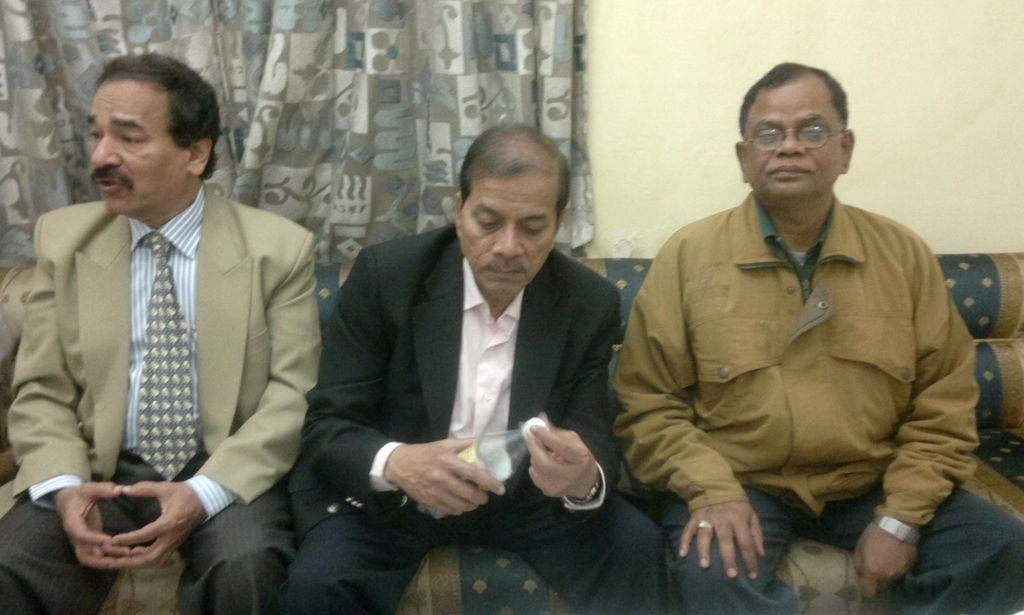In one or two sentences, can you explain what this image depicts? In this image, we can see some people sitting on the sofa, there is a curtain and we can see a cream color wall. 